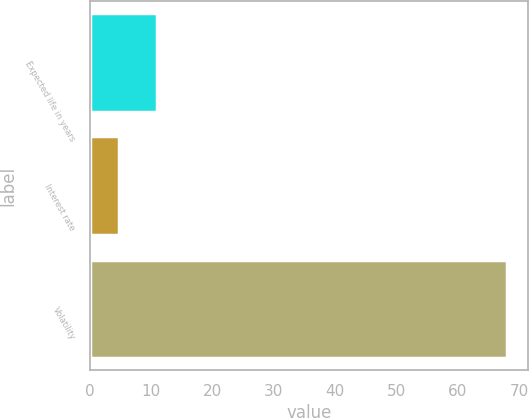<chart> <loc_0><loc_0><loc_500><loc_500><bar_chart><fcel>Expected life in years<fcel>Interest rate<fcel>Volatility<nl><fcel>11.03<fcel>4.7<fcel>68<nl></chart> 